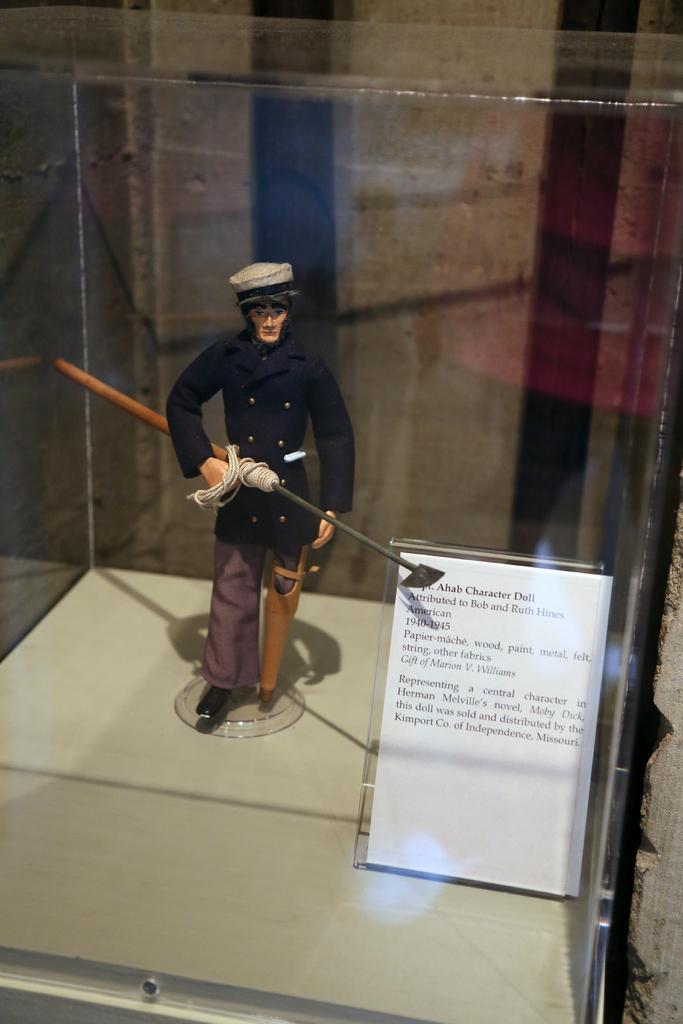Could you give a brief overview of what you see in this image? Here in this picture we can see a toy present in a glass box and holding a weapon and beside that we can see a board with some text present. 